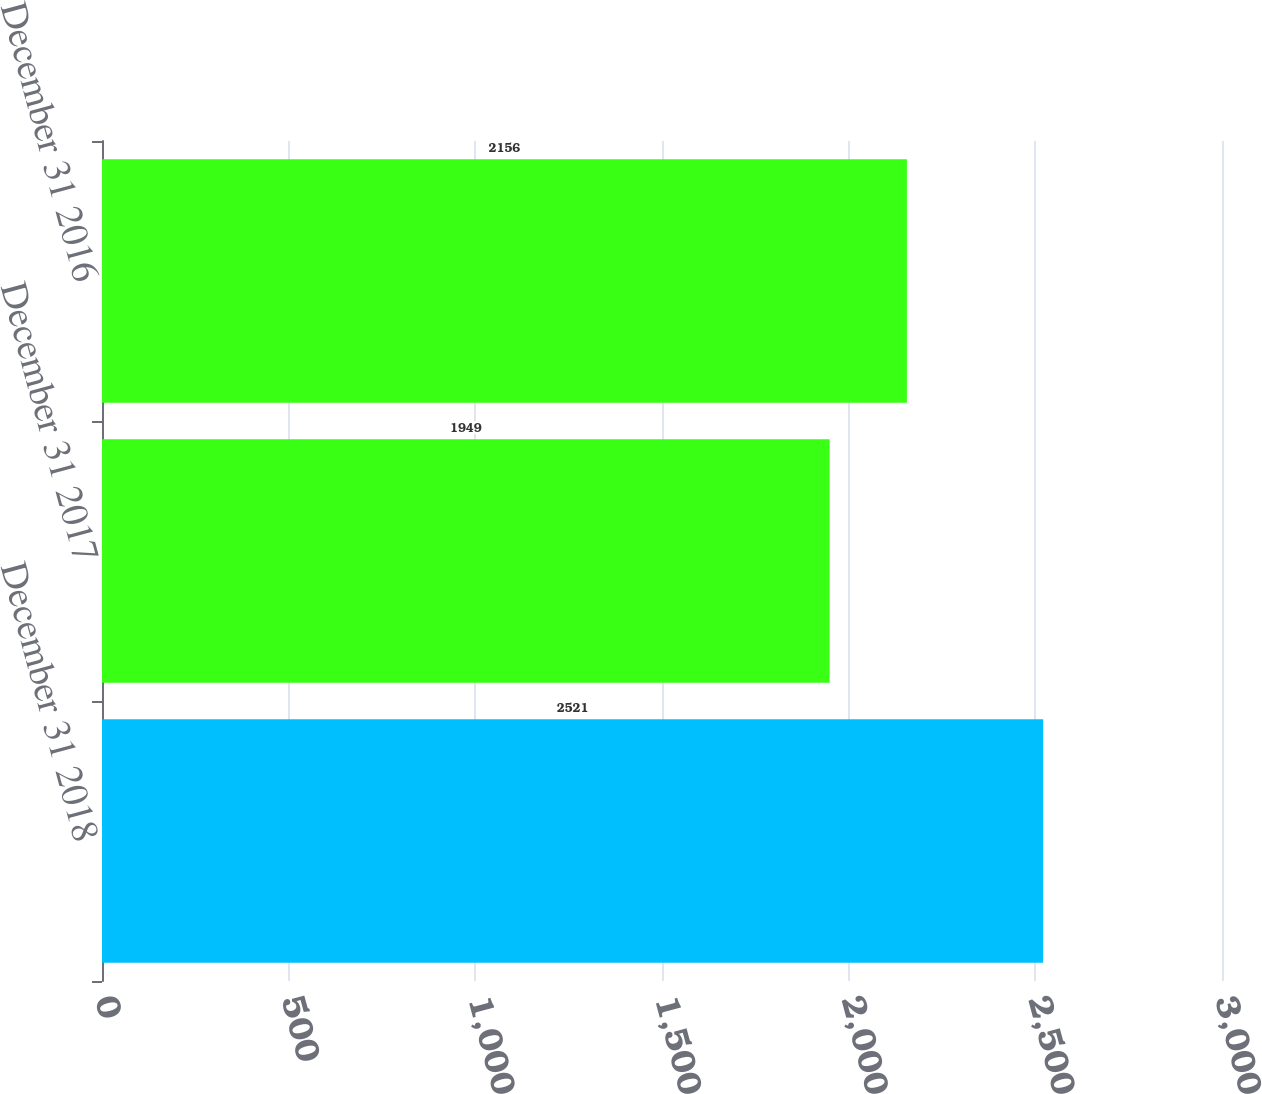Convert chart. <chart><loc_0><loc_0><loc_500><loc_500><bar_chart><fcel>December 31 2018<fcel>December 31 2017<fcel>December 31 2016<nl><fcel>2521<fcel>1949<fcel>2156<nl></chart> 